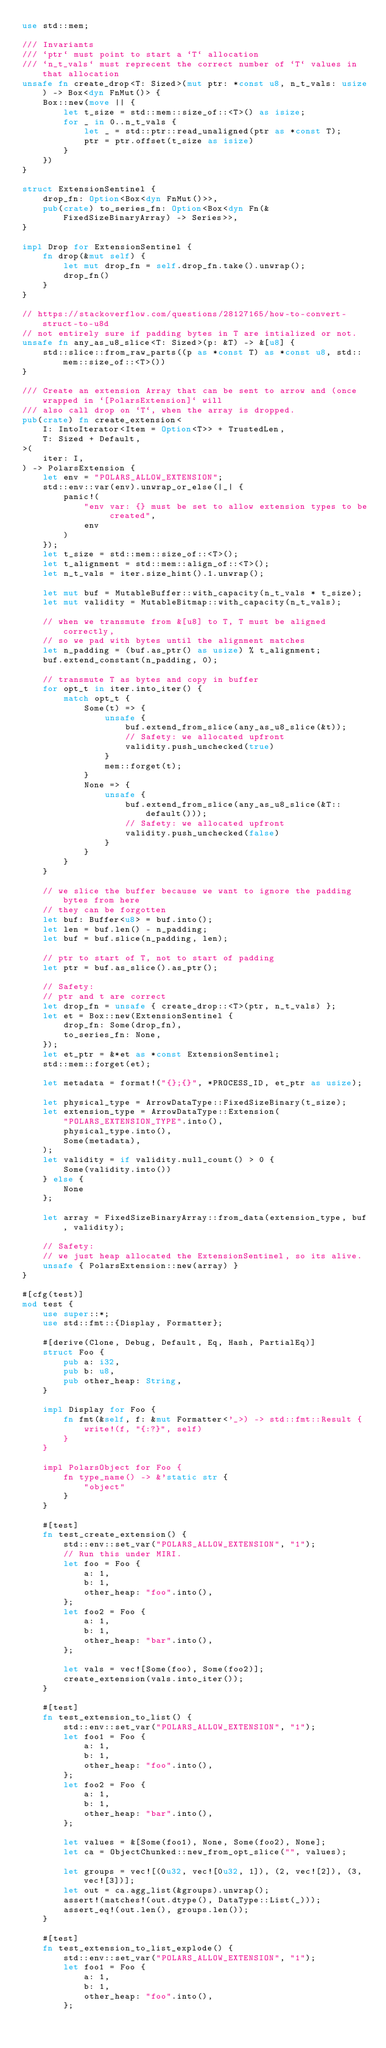Convert code to text. <code><loc_0><loc_0><loc_500><loc_500><_Rust_>use std::mem;

/// Invariants
/// `ptr` must point to start a `T` allocation
/// `n_t_vals` must reprecent the correct number of `T` values in that allocation
unsafe fn create_drop<T: Sized>(mut ptr: *const u8, n_t_vals: usize) -> Box<dyn FnMut()> {
    Box::new(move || {
        let t_size = std::mem::size_of::<T>() as isize;
        for _ in 0..n_t_vals {
            let _ = std::ptr::read_unaligned(ptr as *const T);
            ptr = ptr.offset(t_size as isize)
        }
    })
}

struct ExtensionSentinel {
    drop_fn: Option<Box<dyn FnMut()>>,
    pub(crate) to_series_fn: Option<Box<dyn Fn(&FixedSizeBinaryArray) -> Series>>,
}

impl Drop for ExtensionSentinel {
    fn drop(&mut self) {
        let mut drop_fn = self.drop_fn.take().unwrap();
        drop_fn()
    }
}

// https://stackoverflow.com/questions/28127165/how-to-convert-struct-to-u8d
// not entirely sure if padding bytes in T are intialized or not.
unsafe fn any_as_u8_slice<T: Sized>(p: &T) -> &[u8] {
    std::slice::from_raw_parts((p as *const T) as *const u8, std::mem::size_of::<T>())
}

/// Create an extension Array that can be sent to arrow and (once wrapped in `[PolarsExtension]` will
/// also call drop on `T`, when the array is dropped.
pub(crate) fn create_extension<
    I: IntoIterator<Item = Option<T>> + TrustedLen,
    T: Sized + Default,
>(
    iter: I,
) -> PolarsExtension {
    let env = "POLARS_ALLOW_EXTENSION";
    std::env::var(env).unwrap_or_else(|_| {
        panic!(
            "env var: {} must be set to allow extension types to be created",
            env
        )
    });
    let t_size = std::mem::size_of::<T>();
    let t_alignment = std::mem::align_of::<T>();
    let n_t_vals = iter.size_hint().1.unwrap();

    let mut buf = MutableBuffer::with_capacity(n_t_vals * t_size);
    let mut validity = MutableBitmap::with_capacity(n_t_vals);

    // when we transmute from &[u8] to T, T must be aligned correctly,
    // so we pad with bytes until the alignment matches
    let n_padding = (buf.as_ptr() as usize) % t_alignment;
    buf.extend_constant(n_padding, 0);

    // transmute T as bytes and copy in buffer
    for opt_t in iter.into_iter() {
        match opt_t {
            Some(t) => {
                unsafe {
                    buf.extend_from_slice(any_as_u8_slice(&t));
                    // Safety: we allocated upfront
                    validity.push_unchecked(true)
                }
                mem::forget(t);
            }
            None => {
                unsafe {
                    buf.extend_from_slice(any_as_u8_slice(&T::default()));
                    // Safety: we allocated upfront
                    validity.push_unchecked(false)
                }
            }
        }
    }

    // we slice the buffer because we want to ignore the padding bytes from here
    // they can be forgotten
    let buf: Buffer<u8> = buf.into();
    let len = buf.len() - n_padding;
    let buf = buf.slice(n_padding, len);

    // ptr to start of T, not to start of padding
    let ptr = buf.as_slice().as_ptr();

    // Safety:
    // ptr and t are correct
    let drop_fn = unsafe { create_drop::<T>(ptr, n_t_vals) };
    let et = Box::new(ExtensionSentinel {
        drop_fn: Some(drop_fn),
        to_series_fn: None,
    });
    let et_ptr = &*et as *const ExtensionSentinel;
    std::mem::forget(et);

    let metadata = format!("{};{}", *PROCESS_ID, et_ptr as usize);

    let physical_type = ArrowDataType::FixedSizeBinary(t_size);
    let extension_type = ArrowDataType::Extension(
        "POLARS_EXTENSION_TYPE".into(),
        physical_type.into(),
        Some(metadata),
    );
    let validity = if validity.null_count() > 0 {
        Some(validity.into())
    } else {
        None
    };

    let array = FixedSizeBinaryArray::from_data(extension_type, buf, validity);

    // Safety:
    // we just heap allocated the ExtensionSentinel, so its alive.
    unsafe { PolarsExtension::new(array) }
}

#[cfg(test)]
mod test {
    use super::*;
    use std::fmt::{Display, Formatter};

    #[derive(Clone, Debug, Default, Eq, Hash, PartialEq)]
    struct Foo {
        pub a: i32,
        pub b: u8,
        pub other_heap: String,
    }

    impl Display for Foo {
        fn fmt(&self, f: &mut Formatter<'_>) -> std::fmt::Result {
            write!(f, "{:?}", self)
        }
    }

    impl PolarsObject for Foo {
        fn type_name() -> &'static str {
            "object"
        }
    }

    #[test]
    fn test_create_extension() {
        std::env::set_var("POLARS_ALLOW_EXTENSION", "1");
        // Run this under MIRI.
        let foo = Foo {
            a: 1,
            b: 1,
            other_heap: "foo".into(),
        };
        let foo2 = Foo {
            a: 1,
            b: 1,
            other_heap: "bar".into(),
        };

        let vals = vec![Some(foo), Some(foo2)];
        create_extension(vals.into_iter());
    }

    #[test]
    fn test_extension_to_list() {
        std::env::set_var("POLARS_ALLOW_EXTENSION", "1");
        let foo1 = Foo {
            a: 1,
            b: 1,
            other_heap: "foo".into(),
        };
        let foo2 = Foo {
            a: 1,
            b: 1,
            other_heap: "bar".into(),
        };

        let values = &[Some(foo1), None, Some(foo2), None];
        let ca = ObjectChunked::new_from_opt_slice("", values);

        let groups = vec![(0u32, vec![0u32, 1]), (2, vec![2]), (3, vec![3])];
        let out = ca.agg_list(&groups).unwrap();
        assert!(matches!(out.dtype(), DataType::List(_)));
        assert_eq!(out.len(), groups.len());
    }

    #[test]
    fn test_extension_to_list_explode() {
        std::env::set_var("POLARS_ALLOW_EXTENSION", "1");
        let foo1 = Foo {
            a: 1,
            b: 1,
            other_heap: "foo".into(),
        };</code> 